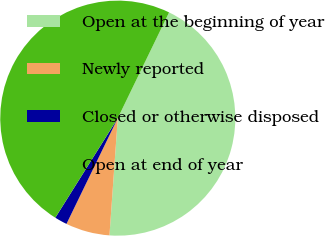Convert chart. <chart><loc_0><loc_0><loc_500><loc_500><pie_chart><fcel>Open at the beginning of year<fcel>Newly reported<fcel>Closed or otherwise disposed<fcel>Open at end of year<nl><fcel>43.94%<fcel>6.06%<fcel>1.73%<fcel>48.27%<nl></chart> 